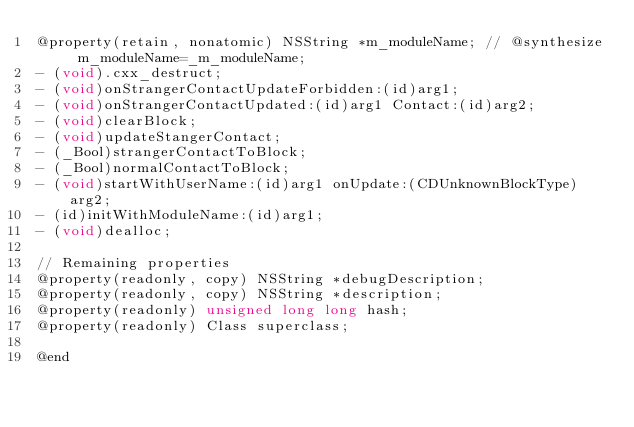<code> <loc_0><loc_0><loc_500><loc_500><_C_>@property(retain, nonatomic) NSString *m_moduleName; // @synthesize m_moduleName=_m_moduleName;
- (void).cxx_destruct;
- (void)onStrangerContactUpdateForbidden:(id)arg1;
- (void)onStrangerContactUpdated:(id)arg1 Contact:(id)arg2;
- (void)clearBlock;
- (void)updateStangerContact;
- (_Bool)strangerContactToBlock;
- (_Bool)normalContactToBlock;
- (void)startWithUserName:(id)arg1 onUpdate:(CDUnknownBlockType)arg2;
- (id)initWithModuleName:(id)arg1;
- (void)dealloc;

// Remaining properties
@property(readonly, copy) NSString *debugDescription;
@property(readonly, copy) NSString *description;
@property(readonly) unsigned long long hash;
@property(readonly) Class superclass;

@end

</code> 